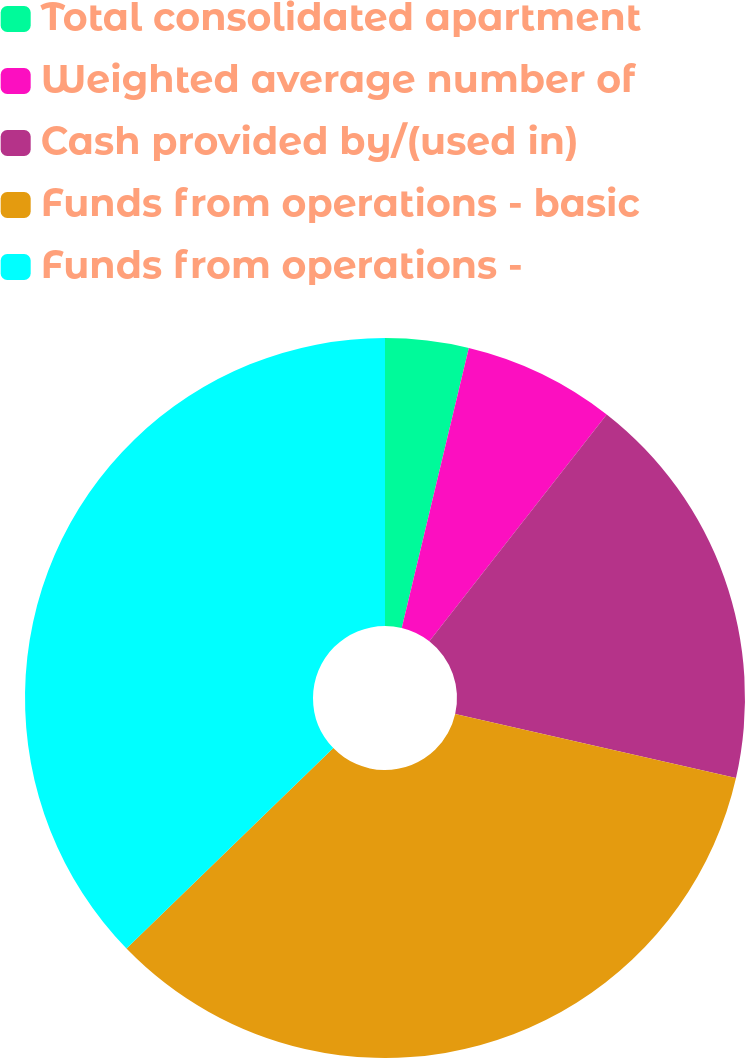<chart> <loc_0><loc_0><loc_500><loc_500><pie_chart><fcel>Total consolidated apartment<fcel>Weighted average number of<fcel>Cash provided by/(used in)<fcel>Funds from operations - basic<fcel>Funds from operations -<nl><fcel>3.74%<fcel>6.82%<fcel>18.01%<fcel>34.18%<fcel>37.25%<nl></chart> 